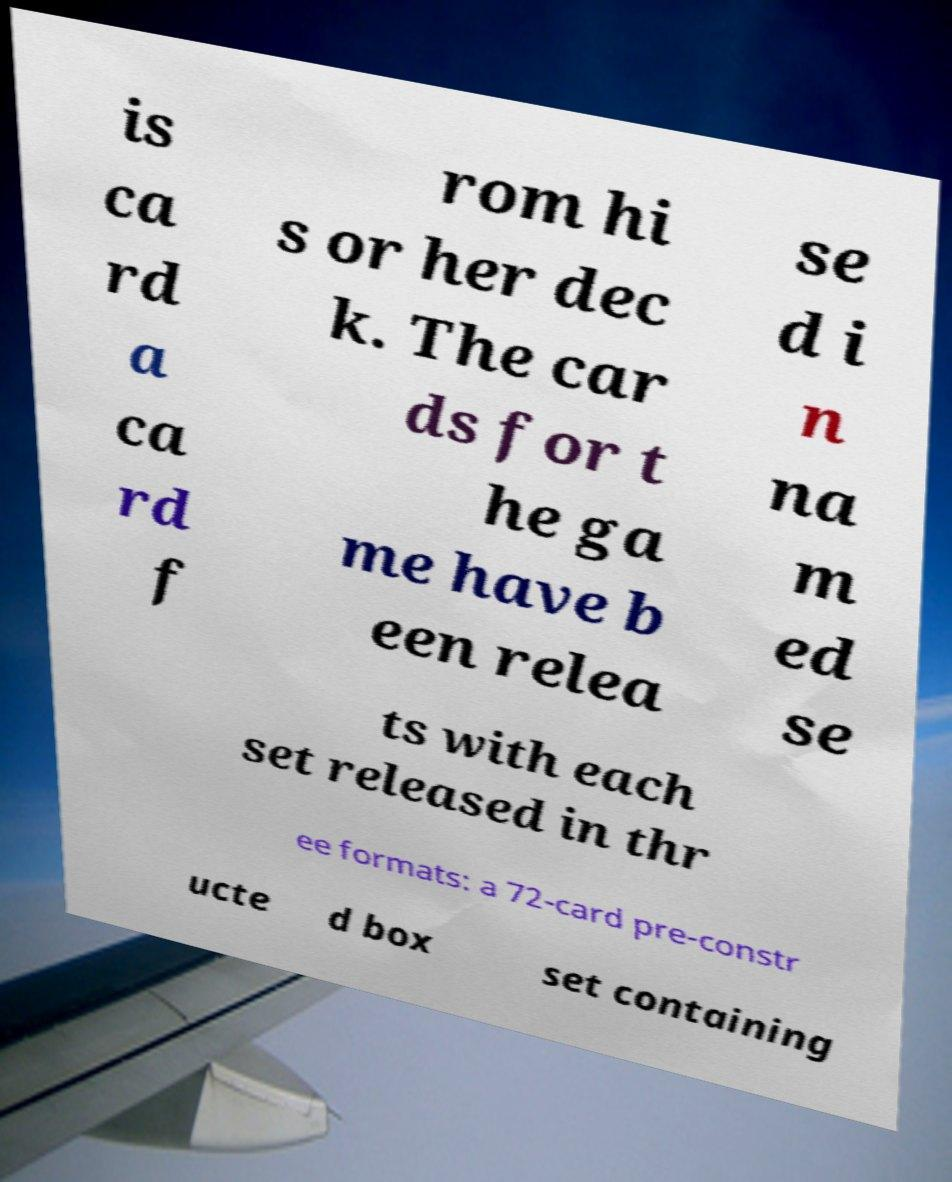Can you accurately transcribe the text from the provided image for me? is ca rd a ca rd f rom hi s or her dec k. The car ds for t he ga me have b een relea se d i n na m ed se ts with each set released in thr ee formats: a 72-card pre-constr ucte d box set containing 